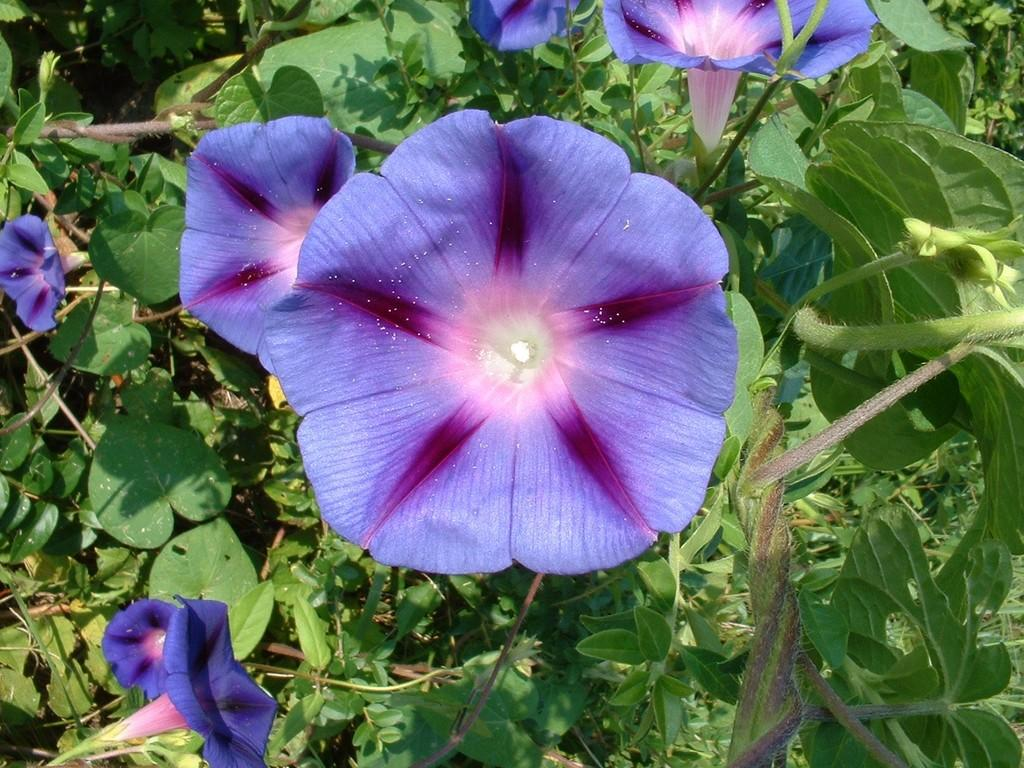What is the main subject in the foreground of the image? There is a beautiful flower in the foreground of the image. Are there any other flowers visible in the image? Yes, there are other flowers around the beautiful flower. What else can be seen in the image besides flowers? There are plants present in the image. How many brothers are playing with the tooth in the image? There are no brothers or teeth present in the image; it features flowers and plants. 